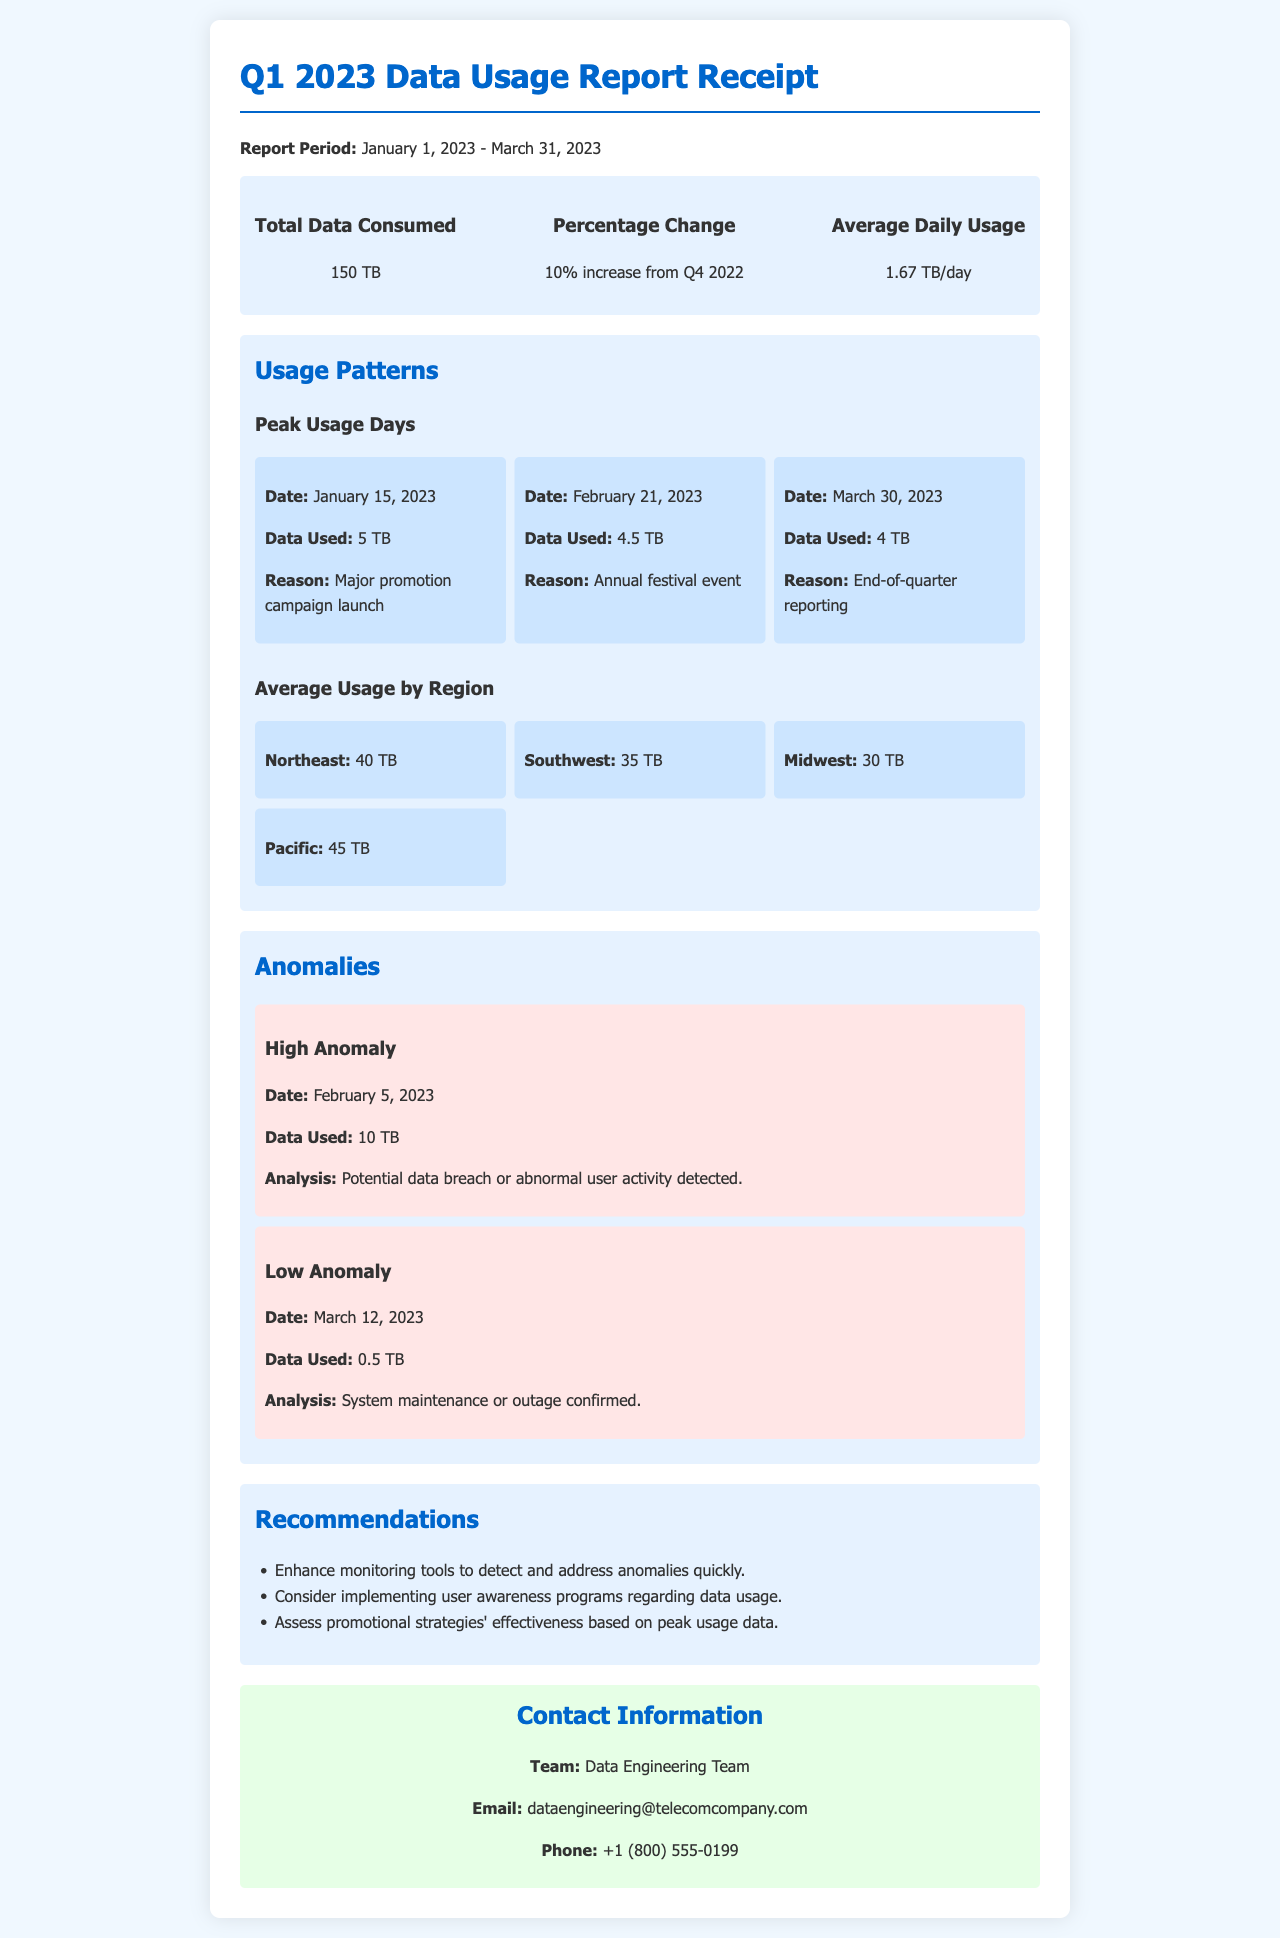What is the total data consumed? The total data consumed over the report period is stated in the summary section as 150 TB.
Answer: 150 TB What was the percentage change in data usage? The percentage change from the previous quarter (Q4 2022) is noted as a 10% increase.
Answer: 10% increase What was the average daily usage? The average daily usage is provided in the summary section as 1.67 TB/day.
Answer: 1.67 TB/day On what date did the highest data usage occur? The highest usage day is listed as January 15, 2023, with 5 TB used for a specific reason.
Answer: January 15, 2023 What was the primary reason for peak usage on February 21, 2023? The document states that the reason for peak usage on this date was an annual festival event.
Answer: Annual festival event How much data was consumed on March 30, 2023? The data used on March 30, 2023, is reported as 4 TB in the usage patterns section.
Answer: 4 TB What anomaly was detected on February 5, 2023? The report indicates a high anomaly, which is a potential data breach or abnormal user activity detected.
Answer: Potential data breach or abnormal user activity detected What is one recommendation from the report? The report provides several recommendations, one of which is to enhance monitoring tools to detect anomalies quickly.
Answer: Enhance monitoring tools to detect anomalies quickly Which region had the highest average usage? The report specifies that the Pacific region had the highest usage at 45 TB during the report period.
Answer: Pacific 